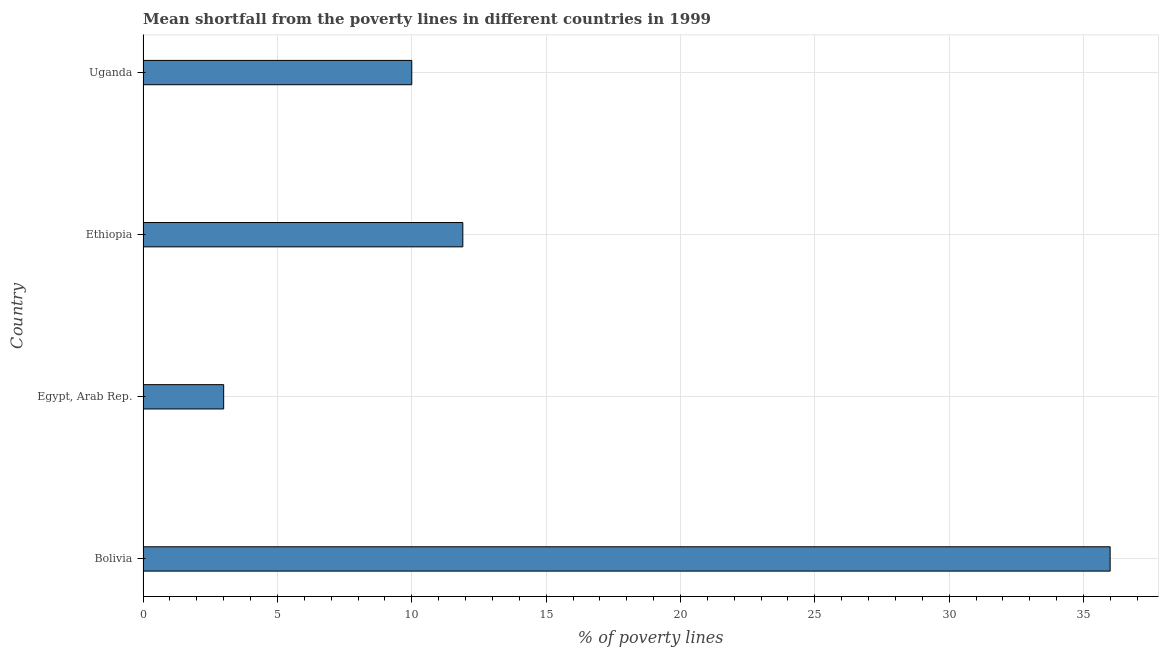Does the graph contain any zero values?
Offer a terse response. No. What is the title of the graph?
Make the answer very short. Mean shortfall from the poverty lines in different countries in 1999. What is the label or title of the X-axis?
Your answer should be very brief. % of poverty lines. What is the poverty gap at national poverty lines in Uganda?
Give a very brief answer. 10. Across all countries, what is the maximum poverty gap at national poverty lines?
Offer a terse response. 35.99. Across all countries, what is the minimum poverty gap at national poverty lines?
Your response must be concise. 3. In which country was the poverty gap at national poverty lines maximum?
Offer a terse response. Bolivia. In which country was the poverty gap at national poverty lines minimum?
Offer a terse response. Egypt, Arab Rep. What is the sum of the poverty gap at national poverty lines?
Make the answer very short. 60.89. What is the difference between the poverty gap at national poverty lines in Bolivia and Ethiopia?
Provide a short and direct response. 24.09. What is the average poverty gap at national poverty lines per country?
Provide a short and direct response. 15.22. What is the median poverty gap at national poverty lines?
Your answer should be very brief. 10.95. What is the ratio of the poverty gap at national poverty lines in Egypt, Arab Rep. to that in Ethiopia?
Your answer should be compact. 0.25. Is the difference between the poverty gap at national poverty lines in Ethiopia and Uganda greater than the difference between any two countries?
Your answer should be very brief. No. What is the difference between the highest and the second highest poverty gap at national poverty lines?
Provide a short and direct response. 24.09. Is the sum of the poverty gap at national poverty lines in Bolivia and Egypt, Arab Rep. greater than the maximum poverty gap at national poverty lines across all countries?
Offer a very short reply. Yes. What is the difference between the highest and the lowest poverty gap at national poverty lines?
Your response must be concise. 32.99. In how many countries, is the poverty gap at national poverty lines greater than the average poverty gap at national poverty lines taken over all countries?
Keep it short and to the point. 1. How many bars are there?
Keep it short and to the point. 4. Are all the bars in the graph horizontal?
Keep it short and to the point. Yes. What is the % of poverty lines of Bolivia?
Offer a very short reply. 35.99. What is the difference between the % of poverty lines in Bolivia and Egypt, Arab Rep.?
Your response must be concise. 32.99. What is the difference between the % of poverty lines in Bolivia and Ethiopia?
Provide a short and direct response. 24.09. What is the difference between the % of poverty lines in Bolivia and Uganda?
Keep it short and to the point. 25.99. What is the difference between the % of poverty lines in Egypt, Arab Rep. and Ethiopia?
Keep it short and to the point. -8.9. What is the ratio of the % of poverty lines in Bolivia to that in Egypt, Arab Rep.?
Ensure brevity in your answer.  12. What is the ratio of the % of poverty lines in Bolivia to that in Ethiopia?
Keep it short and to the point. 3.02. What is the ratio of the % of poverty lines in Bolivia to that in Uganda?
Your answer should be very brief. 3.6. What is the ratio of the % of poverty lines in Egypt, Arab Rep. to that in Ethiopia?
Your response must be concise. 0.25. What is the ratio of the % of poverty lines in Ethiopia to that in Uganda?
Give a very brief answer. 1.19. 